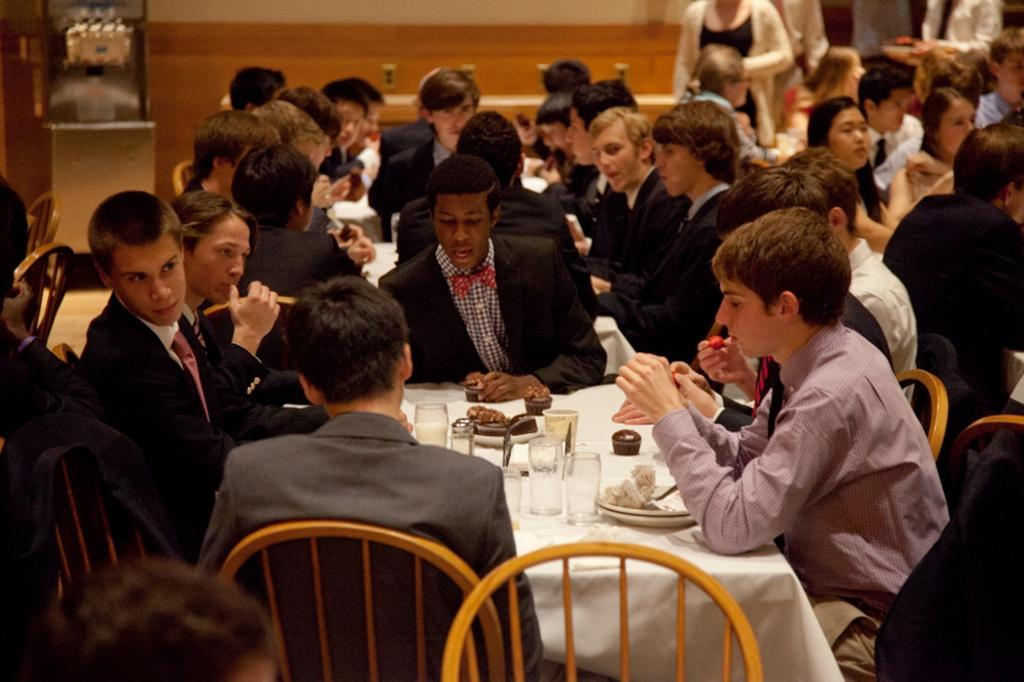How many people are in the image? There is a group of people in the image, but the exact number is not specified. What are the people in the image doing? The people in the image are sitting. What is in front of the group of people? There is a table in front of the group of people. What type of oil is being used in the battle depicted in the image? There is no battle or oil present in the image; it features a group of people sitting around a table. What kind of paper is being used by the people in the image? There is no paper visible in the image; it only shows a group of people sitting around a table. 